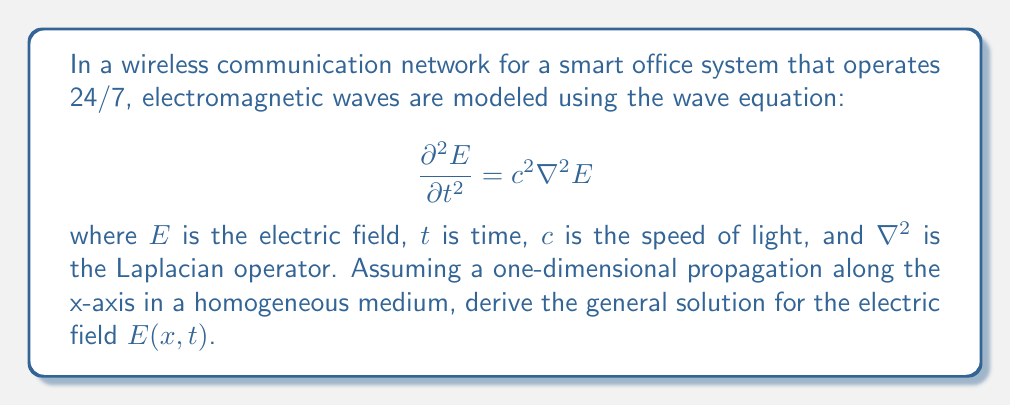Teach me how to tackle this problem. To solve this problem, we'll follow these steps:

1) First, we simplify the wave equation for one-dimensional propagation along the x-axis:

   $$\frac{\partial^2 E}{\partial t^2} = c^2 \frac{\partial^2 E}{\partial x^2}$$

2) The general solution to this equation is of the form:

   $$E(x,t) = f(x-ct) + g(x+ct)$$

   where $f$ and $g$ are arbitrary functions.

3) To verify this solution, we can substitute it into the wave equation:

   $$\frac{\partial^2 E}{\partial t^2} = c^2 f''(x-ct) + c^2 g''(x+ct)$$
   $$\frac{\partial^2 E}{\partial x^2} = f''(x-ct) + g''(x+ct)$$

   We can see that these are equal when multiplied by $c^2$, confirming our solution.

4) Physically, $f(x-ct)$ represents a wave traveling in the positive x-direction, while $g(x+ct)$ represents a wave traveling in the negative x-direction.

5) The specific forms of $f$ and $g$ depend on the initial and boundary conditions of the problem. For example, in a wireless network, these could be determined by the signal transmitted from the router.

This solution allows for the modeling of electromagnetic wave propagation in the wireless network, enabling the optimization of signal strength and coverage throughout the office space at all hours.
Answer: The general solution for the electric field $E(x,t)$ in one-dimensional propagation along the x-axis is:

$$E(x,t) = f(x-ct) + g(x+ct)$$

where $f$ and $g$ are arbitrary functions determined by the specific initial and boundary conditions of the wireless network. 